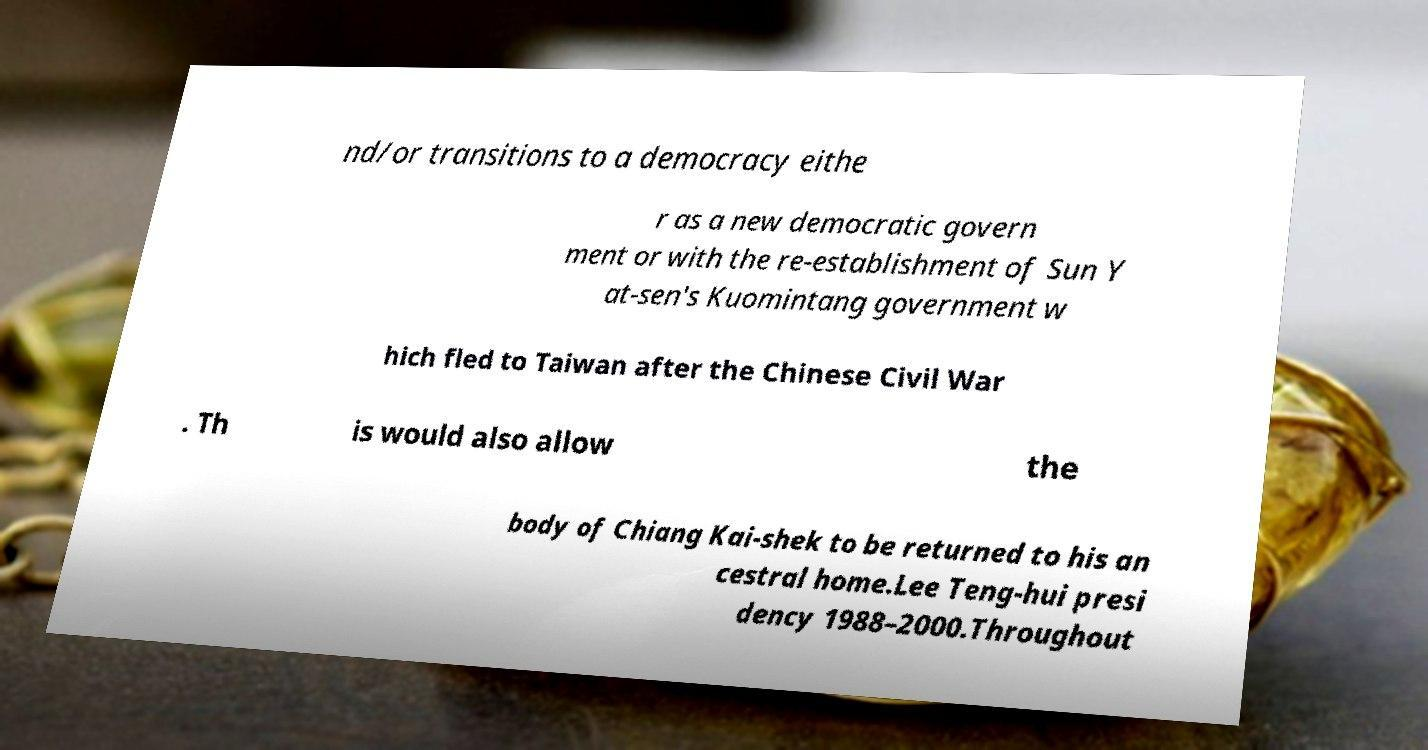Can you accurately transcribe the text from the provided image for me? nd/or transitions to a democracy eithe r as a new democratic govern ment or with the re-establishment of Sun Y at-sen's Kuomintang government w hich fled to Taiwan after the Chinese Civil War . Th is would also allow the body of Chiang Kai-shek to be returned to his an cestral home.Lee Teng-hui presi dency 1988–2000.Throughout 